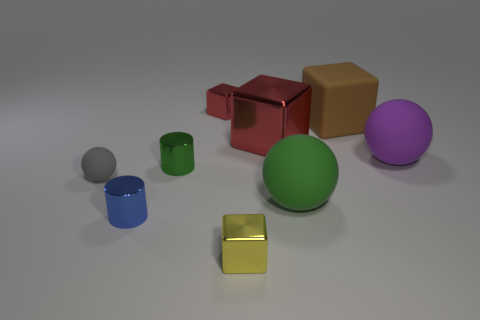Subtract all red cylinders. How many red cubes are left? 2 Add 1 small shiny blocks. How many objects exist? 10 Subtract all large purple matte balls. How many balls are left? 2 Subtract all yellow blocks. How many blocks are left? 3 Subtract all balls. How many objects are left? 6 Add 5 tiny cylinders. How many tiny cylinders exist? 7 Subtract 1 blue cylinders. How many objects are left? 8 Subtract all green cylinders. Subtract all green cubes. How many cylinders are left? 1 Subtract all tiny green shiny cylinders. Subtract all tiny gray matte balls. How many objects are left? 7 Add 5 purple matte objects. How many purple matte objects are left? 6 